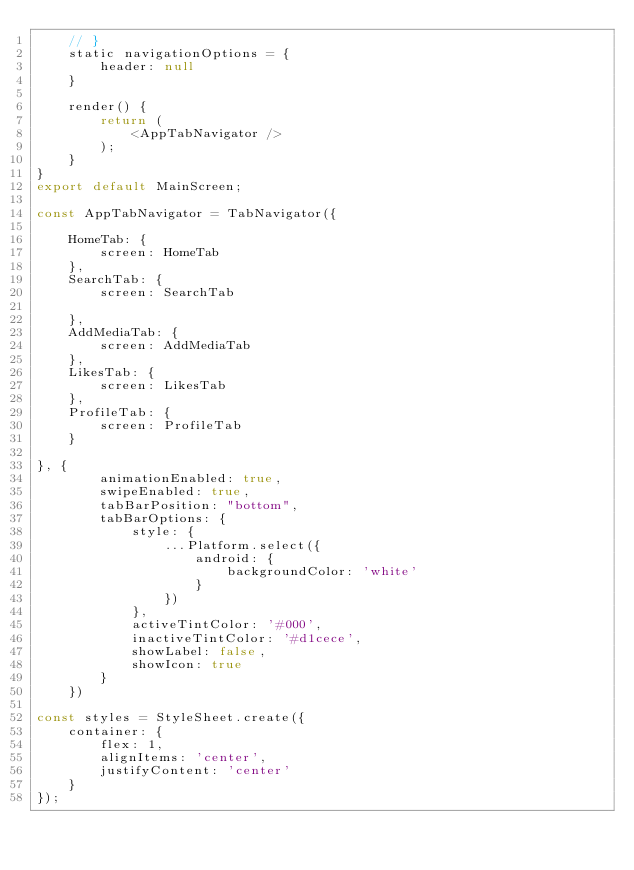<code> <loc_0><loc_0><loc_500><loc_500><_JavaScript_>    // }
    static navigationOptions = {
        header: null
    }

    render() {
        return (
            <AppTabNavigator />
        );
    }
}
export default MainScreen;

const AppTabNavigator = TabNavigator({

    HomeTab: {
        screen: HomeTab
    },
    SearchTab: {
        screen: SearchTab

    },
    AddMediaTab: {
        screen: AddMediaTab
    },
    LikesTab: {
        screen: LikesTab
    },
    ProfileTab: {
        screen: ProfileTab
    }

}, {
        animationEnabled: true,
        swipeEnabled: true,
        tabBarPosition: "bottom",
        tabBarOptions: {
            style: {
                ...Platform.select({
                    android: {
                        backgroundColor: 'white'
                    }
                })
            },
            activeTintColor: '#000',
            inactiveTintColor: '#d1cece',
            showLabel: false,
            showIcon: true
        }
    })

const styles = StyleSheet.create({
    container: {
        flex: 1,
        alignItems: 'center',
        justifyContent: 'center'
    }
});</code> 